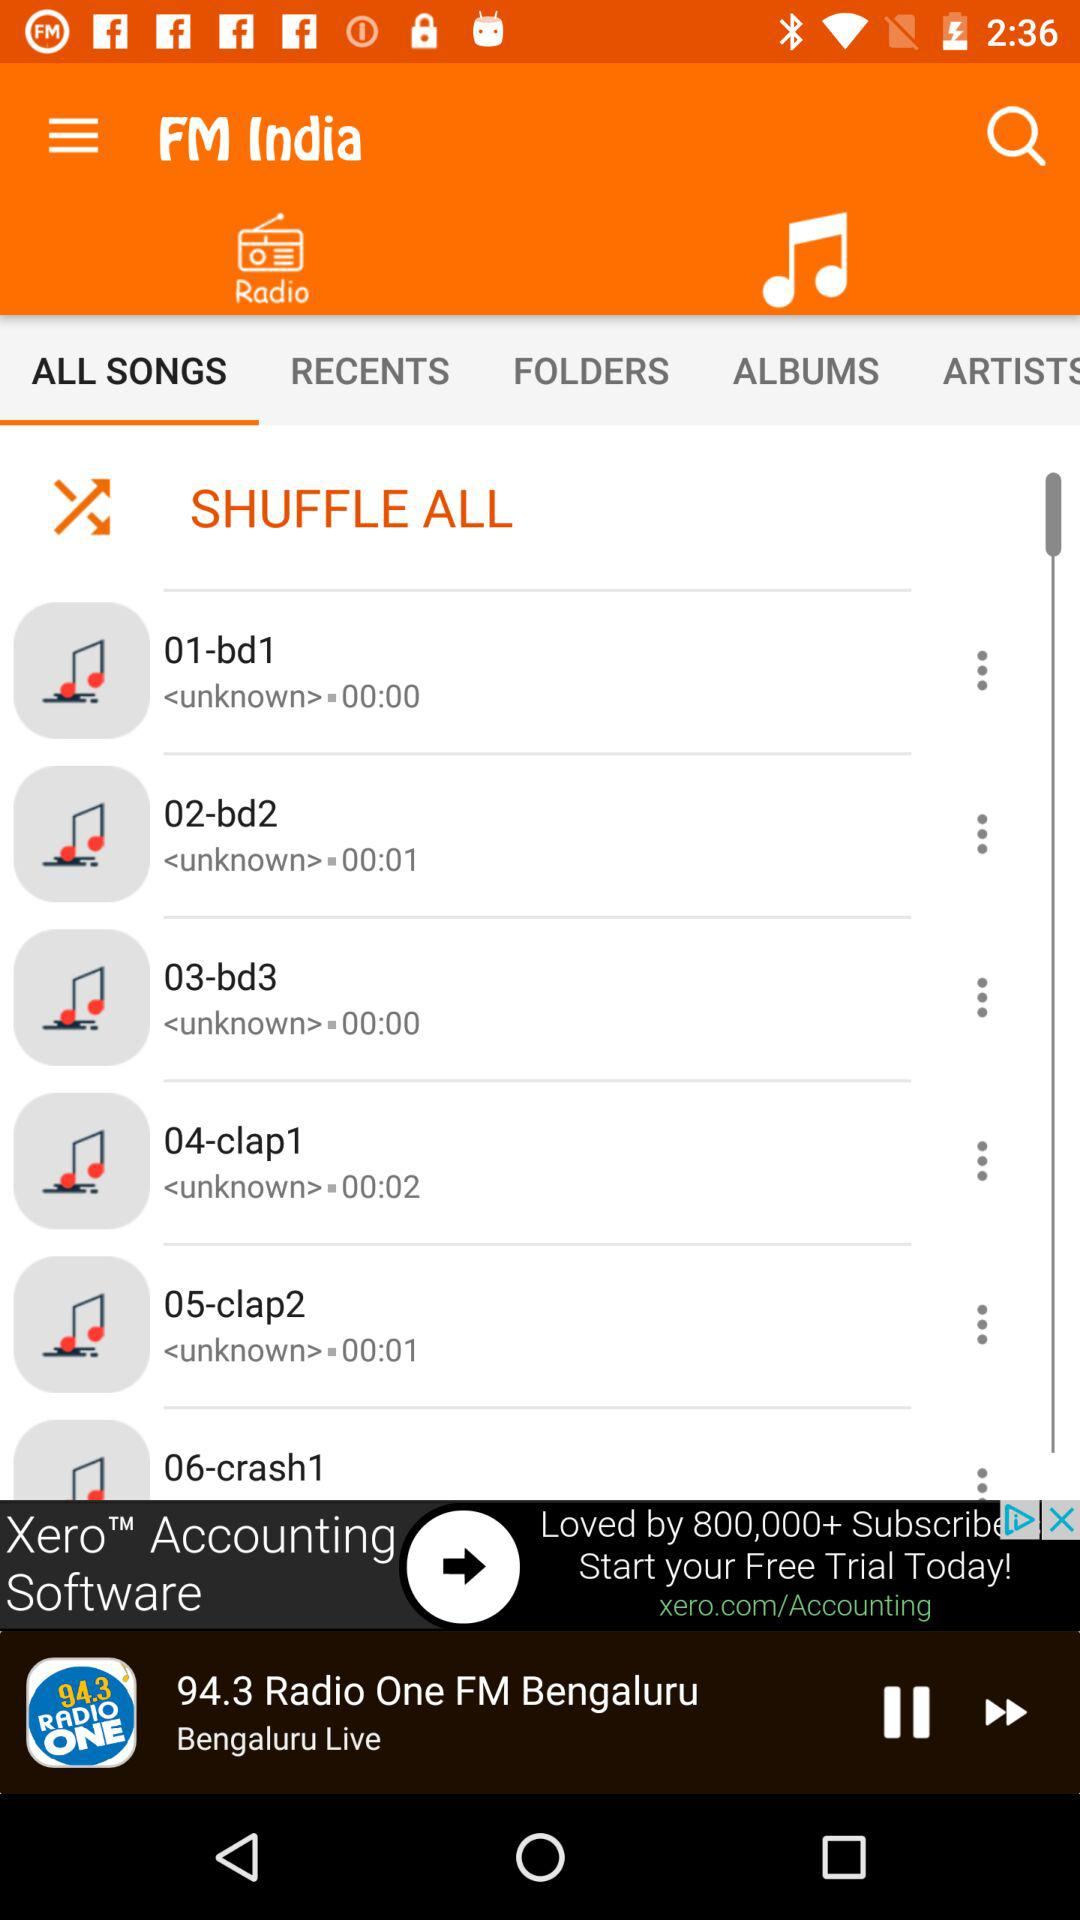What is the name of the live playing radio station? The name of the live playing radio station "94.3 Radio One FM Bengaluru". 